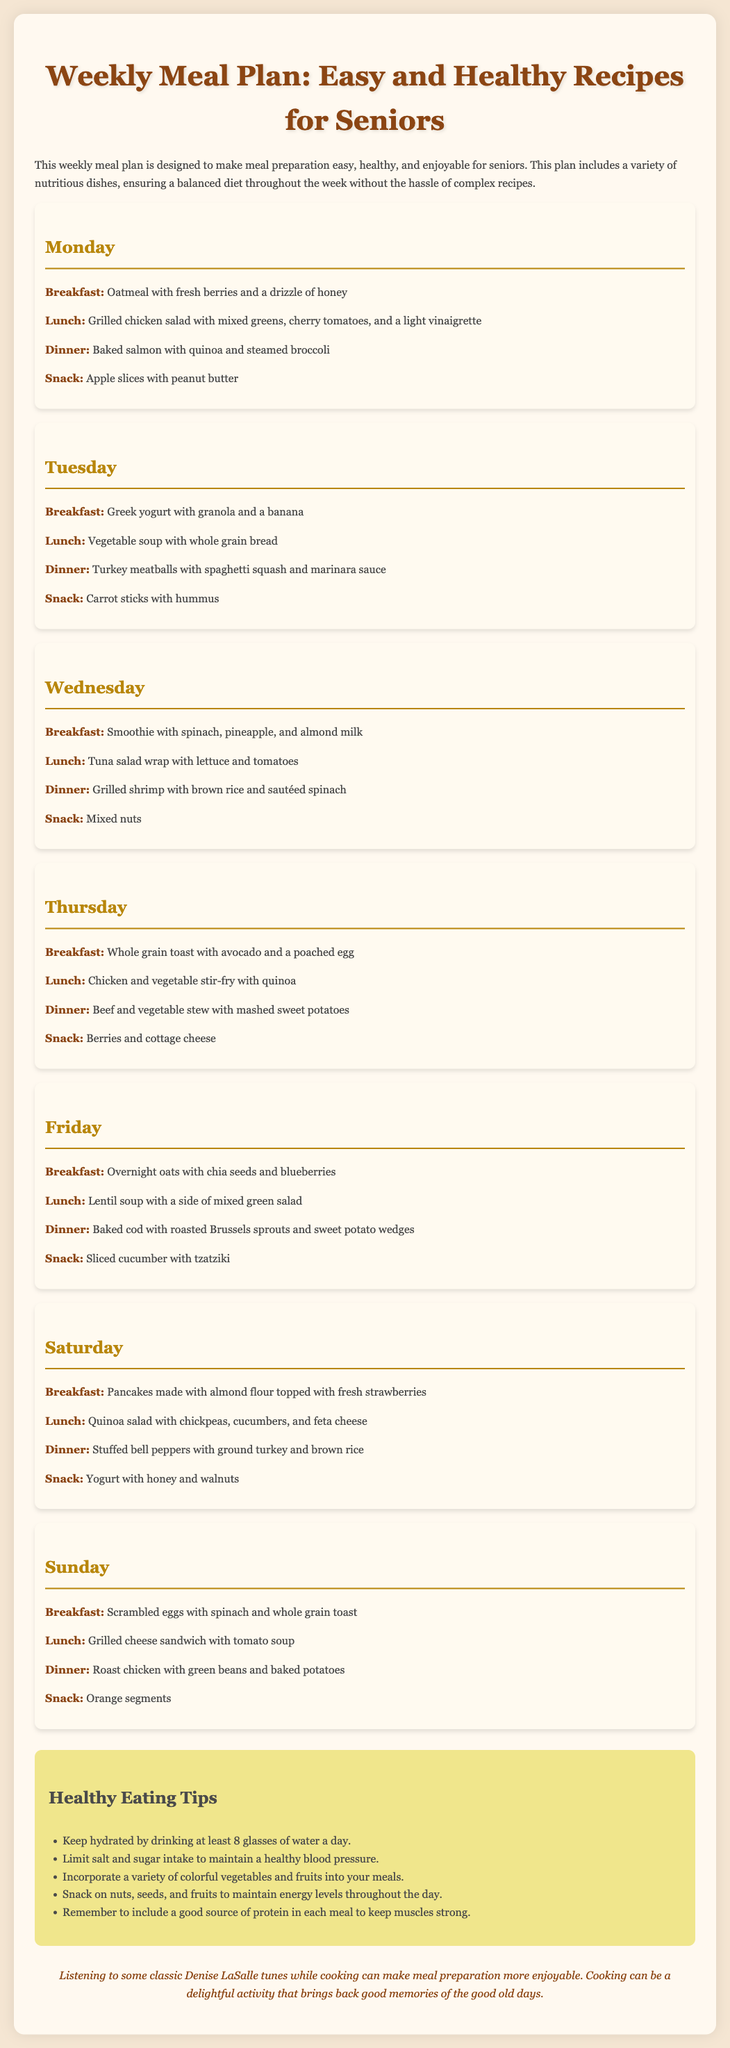What is the first meal listed for Monday? The first meal listed for Monday is breakfast, which is oatmeal with fresh berries and a drizzle of honey.
Answer: oatmeal with fresh berries and a drizzle of honey What type of protein is served for dinner on Tuesday? The protein served for dinner on Tuesday is turkey, specifically turkey meatballs.
Answer: turkey meatballs How many snacks are included in the weekly meal plan? The document outlines one snack for each day of the week, totaling seven snacks.
Answer: seven What is a suggested drink to keep hydrated mentioned in the tips? The tips recommend drinking at least eight glasses of water a day to stay hydrated.
Answer: water Which vegetable is included in the breakfast on Thursday? The breakfast on Thursday features avocado and a poached egg, but there is no vegetable listed; it focuses on the toast.
Answer: avocado What is the color of the meal-day sections in the document? The meal-day sections have a background color described as "light" or "off" white, specifically indicated as #fffaf0.
Answer: #fffaf0 How is the meal plan designed for seniors described in the document? The meal plan is described as making meal preparation easy, healthy, and enjoyable for seniors.
Answer: easy, healthy, and enjoyable Which fruit is paired with cottage cheese for a snack on Thursday? On Thursday, berries are paired with cottage cheese for a snack.
Answer: berries 